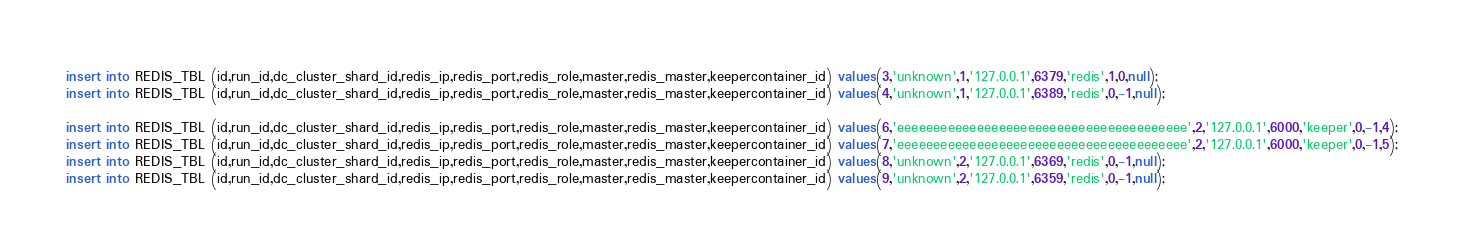<code> <loc_0><loc_0><loc_500><loc_500><_SQL_>insert into REDIS_TBL (id,run_id,dc_cluster_shard_id,redis_ip,redis_port,redis_role,master,redis_master,keepercontainer_id) values(3,'unknown',1,'127.0.0.1',6379,'redis',1,0,null);
insert into REDIS_TBL (id,run_id,dc_cluster_shard_id,redis_ip,redis_port,redis_role,master,redis_master,keepercontainer_id) values(4,'unknown',1,'127.0.0.1',6389,'redis',0,-1,null);

insert into REDIS_TBL (id,run_id,dc_cluster_shard_id,redis_ip,redis_port,redis_role,master,redis_master,keepercontainer_id) values(6,'eeeeeeeeeeeeeeeeeeeeeeeeeeeeeeeeeeeeeeee',2,'127.0.0.1',6000,'keeper',0,-1,4);
insert into REDIS_TBL (id,run_id,dc_cluster_shard_id,redis_ip,redis_port,redis_role,master,redis_master,keepercontainer_id) values(7,'eeeeeeeeeeeeeeeeeeeeeeeeeeeeeeeeeeeeeeee',2,'127.0.0.1',6000,'keeper',0,-1,5);
insert into REDIS_TBL (id,run_id,dc_cluster_shard_id,redis_ip,redis_port,redis_role,master,redis_master,keepercontainer_id) values(8,'unknown',2,'127.0.0.1',6369,'redis',0,-1,null);
insert into REDIS_TBL (id,run_id,dc_cluster_shard_id,redis_ip,redis_port,redis_role,master,redis_master,keepercontainer_id) values(9,'unknown',2,'127.0.0.1',6359,'redis',0,-1,null);</code> 